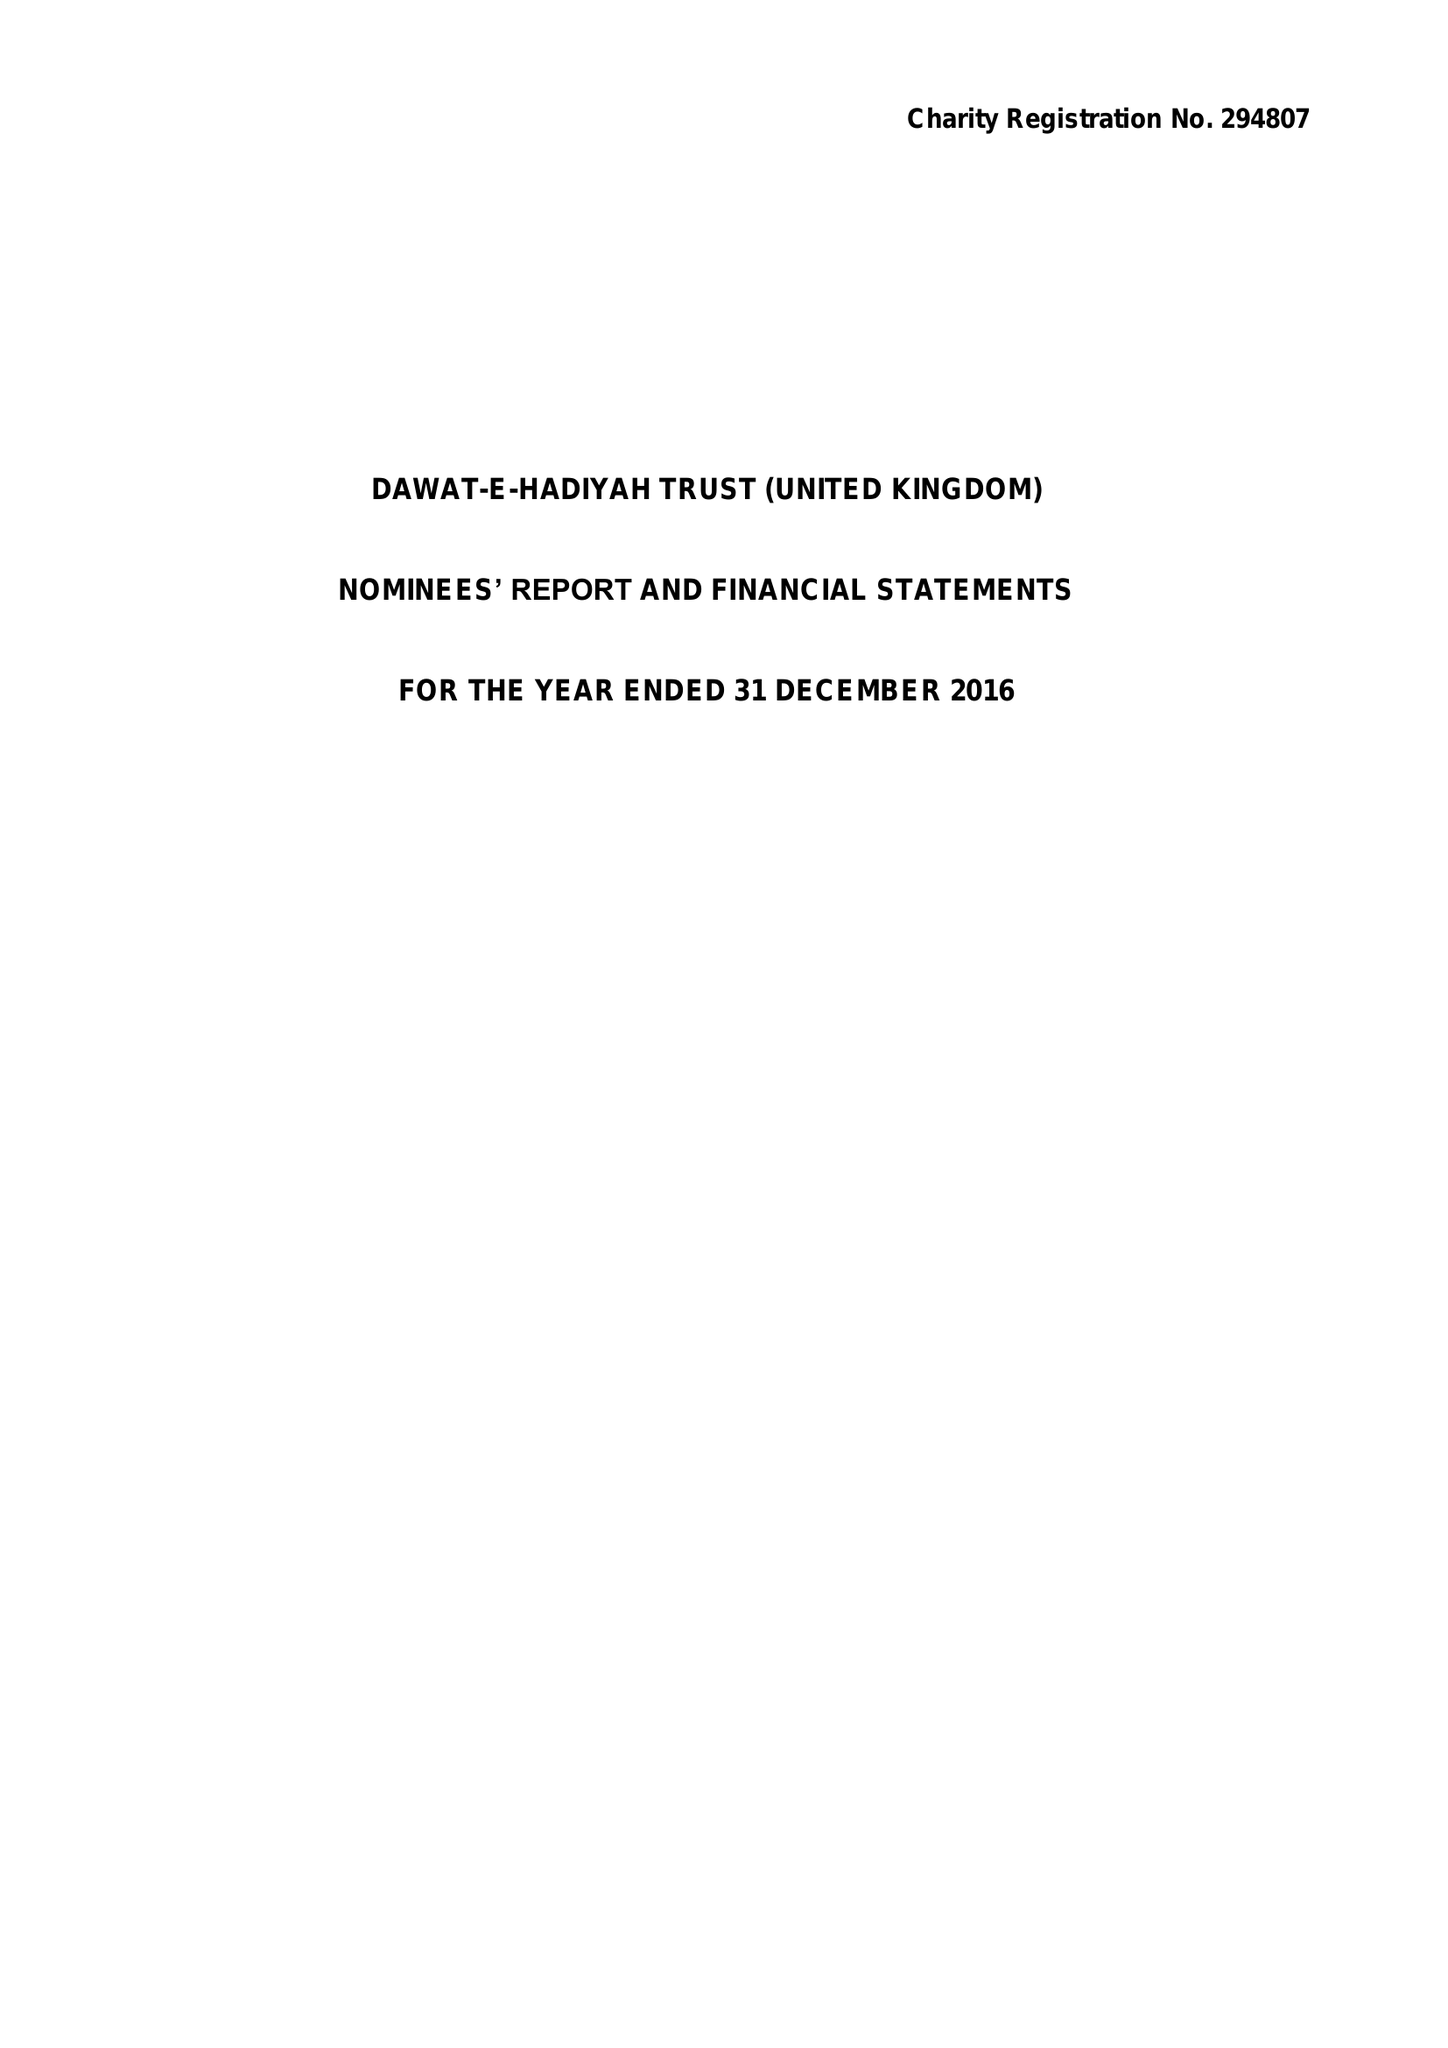What is the value for the address__post_town?
Answer the question using a single word or phrase. GREENFORD 